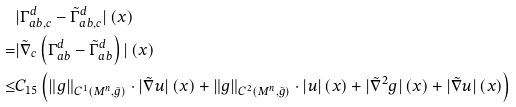Convert formula to latex. <formula><loc_0><loc_0><loc_500><loc_500>& | \Gamma _ { a b , c } ^ { d } - \tilde { \Gamma } _ { a b , c } ^ { d } | \left ( x \right ) \\ = & | \tilde { \nabla } _ { c } \left ( \Gamma _ { a b } ^ { d } - \tilde { \Gamma } _ { a b } ^ { d } \right ) | \left ( x \right ) \\ \leq & C _ { 1 5 } \left ( \| g \| _ { C ^ { 1 } \left ( M ^ { n } , \tilde { g } \right ) } \cdot | \tilde { \nabla } u | \left ( x \right ) + \| g \| _ { C ^ { 2 } \left ( M ^ { n } , \tilde { g } \right ) } \cdot | u | \left ( x \right ) + | \tilde { \nabla } ^ { 2 } g | \left ( x \right ) + | \tilde { \nabla } u | \left ( x \right ) \right ) \\</formula> 